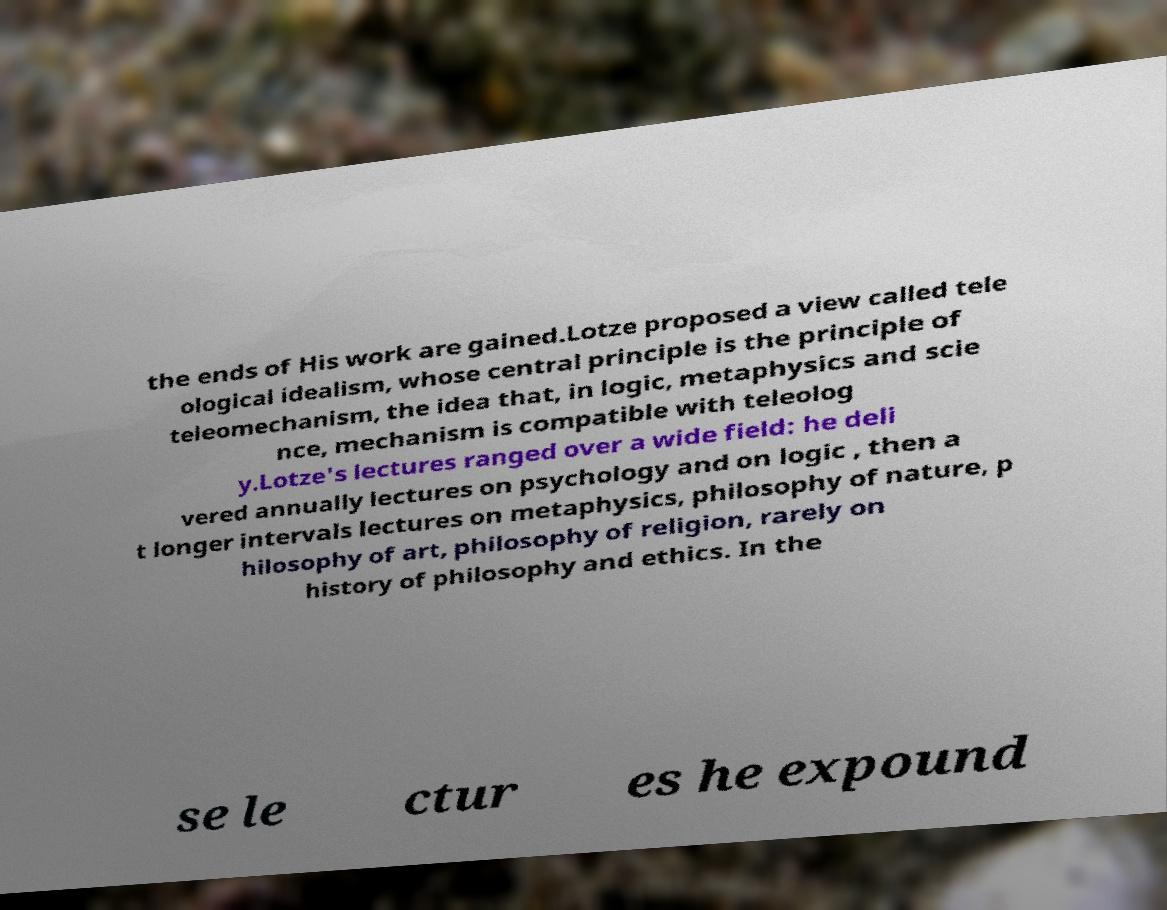For documentation purposes, I need the text within this image transcribed. Could you provide that? the ends of His work are gained.Lotze proposed a view called tele ological idealism, whose central principle is the principle of teleomechanism, the idea that, in logic, metaphysics and scie nce, mechanism is compatible with teleolog y.Lotze's lectures ranged over a wide field: he deli vered annually lectures on psychology and on logic , then a t longer intervals lectures on metaphysics, philosophy of nature, p hilosophy of art, philosophy of religion, rarely on history of philosophy and ethics. In the se le ctur es he expound 